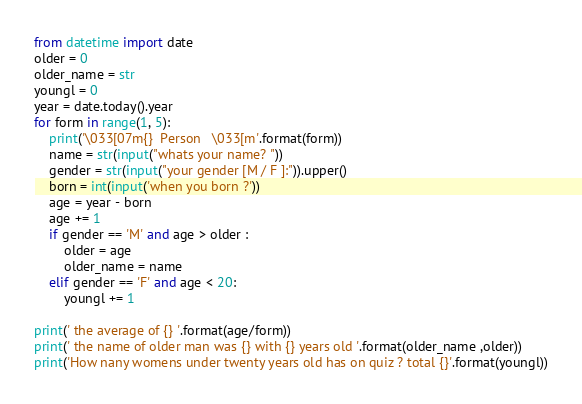<code> <loc_0><loc_0><loc_500><loc_500><_Python_>from datetime import date
older = 0
older_name = str
youngl = 0
year = date.today().year
for form in range(1, 5):
    print('\033[07m{}  Person   \033[m'.format(form))
    name = str(input("whats your name? "))
    gender = str(input("your gender [M / F ]:")).upper()
    born = int(input('when you born ?'))
    age = year - born
    age += 1
    if gender == 'M' and age > older :
        older = age
        older_name = name
    elif gender == 'F' and age < 20:
        youngl += 1

print(' the average of {} '.format(age/form))
print(' the name of older man was {} with {} years old '.format(older_name ,older))
print('How nany womens under twenty years old has on quiz ? total {}'.format(youngl))</code> 